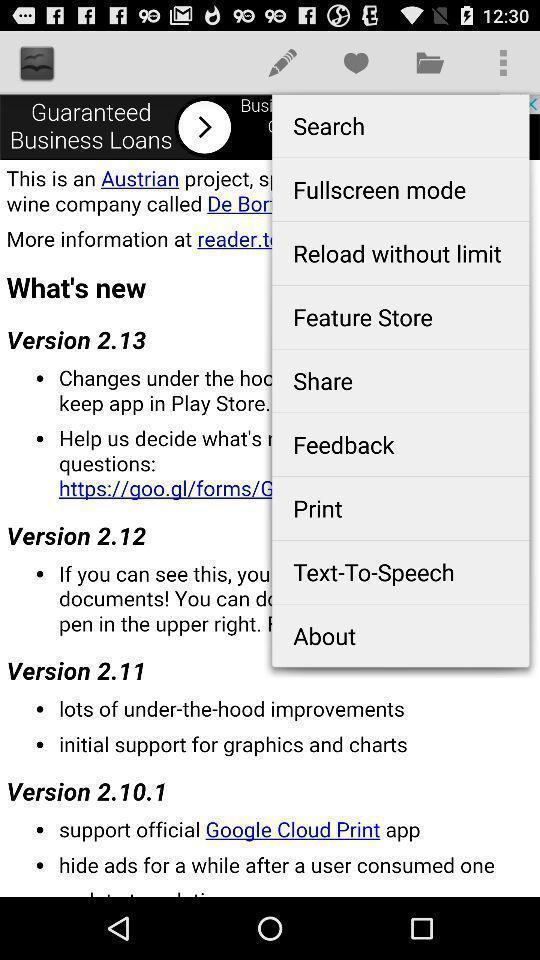Give me a summary of this screen capture. Popup of different options in the application. 